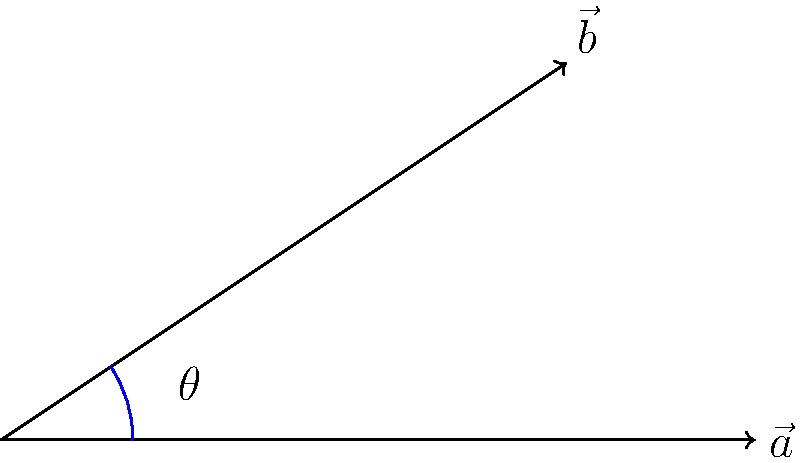The Velika Morava and Zapadna Morava rivers in Serbia can be represented by vectors $\vec{a} = (4, 0)$ and $\vec{b} = (3, 2)$ respectively. Calculate the angle between these two rivers using the dot product formula. Round your answer to the nearest degree. To find the angle between two vectors using the dot product formula, we follow these steps:

1) The dot product formula is: $\vec{a} \cdot \vec{b} = |\vec{a}||\vec{b}|\cos\theta$

2) We know that $\vec{a} = (4, 0)$ and $\vec{b} = (3, 2)$

3) Calculate the dot product:
   $\vec{a} \cdot \vec{b} = 4(3) + 0(2) = 12$

4) Calculate the magnitudes:
   $|\vec{a}| = \sqrt{4^2 + 0^2} = 4$
   $|\vec{b}| = \sqrt{3^2 + 2^2} = \sqrt{13}$

5) Substitute into the formula:
   $12 = 4\sqrt{13}\cos\theta$

6) Solve for $\theta$:
   $\cos\theta = \frac{12}{4\sqrt{13}} = \frac{3}{\sqrt{13}}$

7) Take the inverse cosine (arccos) of both sides:
   $\theta = \arccos(\frac{3}{\sqrt{13}})$

8) Calculate and round to the nearest degree:
   $\theta \approx 33°$
Answer: 33° 